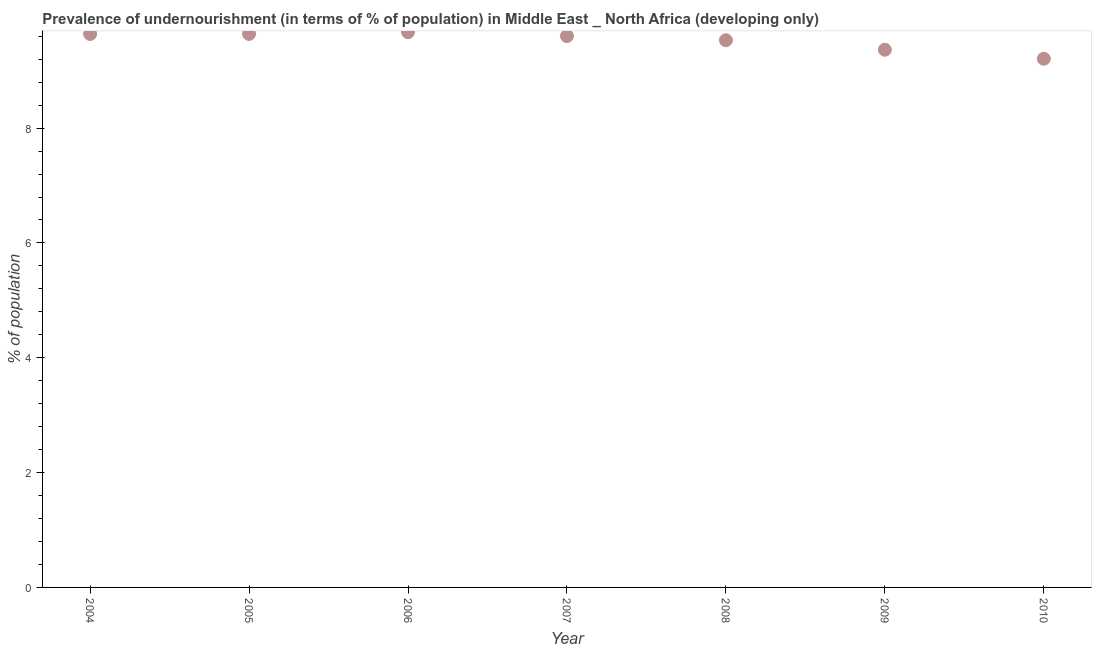What is the percentage of undernourished population in 2008?
Ensure brevity in your answer.  9.53. Across all years, what is the maximum percentage of undernourished population?
Provide a short and direct response. 9.67. Across all years, what is the minimum percentage of undernourished population?
Offer a very short reply. 9.21. In which year was the percentage of undernourished population maximum?
Your answer should be compact. 2006. In which year was the percentage of undernourished population minimum?
Offer a terse response. 2010. What is the sum of the percentage of undernourished population?
Offer a terse response. 66.66. What is the difference between the percentage of undernourished population in 2004 and 2008?
Provide a short and direct response. 0.11. What is the average percentage of undernourished population per year?
Your response must be concise. 9.52. What is the median percentage of undernourished population?
Make the answer very short. 9.6. What is the ratio of the percentage of undernourished population in 2009 to that in 2010?
Provide a succinct answer. 1.02. Is the percentage of undernourished population in 2005 less than that in 2009?
Keep it short and to the point. No. What is the difference between the highest and the second highest percentage of undernourished population?
Provide a succinct answer. 0.03. Is the sum of the percentage of undernourished population in 2009 and 2010 greater than the maximum percentage of undernourished population across all years?
Ensure brevity in your answer.  Yes. What is the difference between the highest and the lowest percentage of undernourished population?
Your answer should be compact. 0.46. How many years are there in the graph?
Your response must be concise. 7. What is the difference between two consecutive major ticks on the Y-axis?
Offer a terse response. 2. Are the values on the major ticks of Y-axis written in scientific E-notation?
Your response must be concise. No. Does the graph contain grids?
Ensure brevity in your answer.  No. What is the title of the graph?
Your answer should be very brief. Prevalence of undernourishment (in terms of % of population) in Middle East _ North Africa (developing only). What is the label or title of the X-axis?
Keep it short and to the point. Year. What is the label or title of the Y-axis?
Keep it short and to the point. % of population. What is the % of population in 2004?
Your answer should be very brief. 9.64. What is the % of population in 2005?
Offer a terse response. 9.64. What is the % of population in 2006?
Your answer should be very brief. 9.67. What is the % of population in 2007?
Keep it short and to the point. 9.6. What is the % of population in 2008?
Provide a short and direct response. 9.53. What is the % of population in 2009?
Your answer should be very brief. 9.37. What is the % of population in 2010?
Make the answer very short. 9.21. What is the difference between the % of population in 2004 and 2005?
Provide a succinct answer. -0. What is the difference between the % of population in 2004 and 2006?
Provide a succinct answer. -0.03. What is the difference between the % of population in 2004 and 2007?
Make the answer very short. 0.04. What is the difference between the % of population in 2004 and 2008?
Ensure brevity in your answer.  0.11. What is the difference between the % of population in 2004 and 2009?
Give a very brief answer. 0.27. What is the difference between the % of population in 2004 and 2010?
Your response must be concise. 0.43. What is the difference between the % of population in 2005 and 2006?
Provide a short and direct response. -0.03. What is the difference between the % of population in 2005 and 2007?
Provide a short and direct response. 0.04. What is the difference between the % of population in 2005 and 2008?
Make the answer very short. 0.11. What is the difference between the % of population in 2005 and 2009?
Provide a succinct answer. 0.28. What is the difference between the % of population in 2005 and 2010?
Keep it short and to the point. 0.43. What is the difference between the % of population in 2006 and 2007?
Provide a short and direct response. 0.07. What is the difference between the % of population in 2006 and 2008?
Your answer should be compact. 0.14. What is the difference between the % of population in 2006 and 2009?
Provide a short and direct response. 0.31. What is the difference between the % of population in 2006 and 2010?
Your answer should be compact. 0.46. What is the difference between the % of population in 2007 and 2008?
Give a very brief answer. 0.07. What is the difference between the % of population in 2007 and 2009?
Provide a succinct answer. 0.24. What is the difference between the % of population in 2007 and 2010?
Offer a terse response. 0.4. What is the difference between the % of population in 2008 and 2009?
Offer a terse response. 0.17. What is the difference between the % of population in 2008 and 2010?
Give a very brief answer. 0.32. What is the difference between the % of population in 2009 and 2010?
Provide a succinct answer. 0.16. What is the ratio of the % of population in 2004 to that in 2006?
Provide a short and direct response. 1. What is the ratio of the % of population in 2004 to that in 2007?
Provide a short and direct response. 1. What is the ratio of the % of population in 2004 to that in 2008?
Provide a short and direct response. 1.01. What is the ratio of the % of population in 2004 to that in 2010?
Ensure brevity in your answer.  1.05. What is the ratio of the % of population in 2005 to that in 2007?
Your response must be concise. 1. What is the ratio of the % of population in 2005 to that in 2010?
Keep it short and to the point. 1.05. What is the ratio of the % of population in 2006 to that in 2009?
Offer a terse response. 1.03. What is the ratio of the % of population in 2007 to that in 2010?
Provide a succinct answer. 1.04. What is the ratio of the % of population in 2008 to that in 2009?
Make the answer very short. 1.02. What is the ratio of the % of population in 2008 to that in 2010?
Your response must be concise. 1.03. 